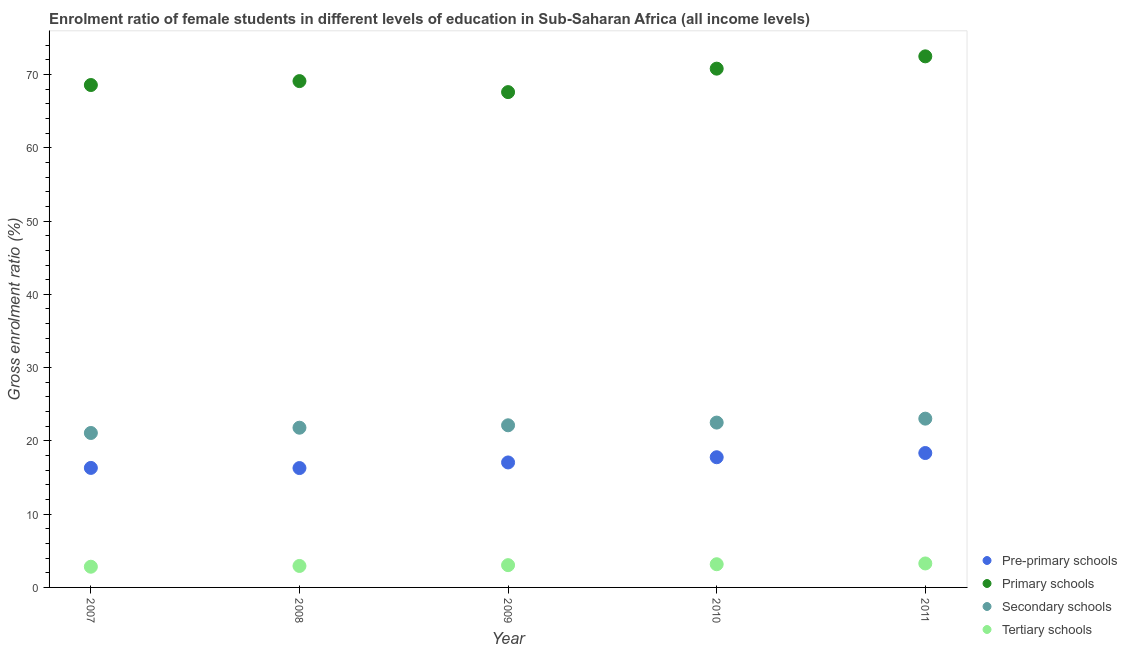How many different coloured dotlines are there?
Make the answer very short. 4. What is the gross enrolment ratio(male) in tertiary schools in 2008?
Your answer should be compact. 2.93. Across all years, what is the maximum gross enrolment ratio(male) in pre-primary schools?
Make the answer very short. 18.34. Across all years, what is the minimum gross enrolment ratio(male) in pre-primary schools?
Offer a terse response. 16.29. In which year was the gross enrolment ratio(male) in primary schools maximum?
Offer a very short reply. 2011. In which year was the gross enrolment ratio(male) in primary schools minimum?
Your answer should be compact. 2009. What is the total gross enrolment ratio(male) in primary schools in the graph?
Offer a very short reply. 348.55. What is the difference between the gross enrolment ratio(male) in secondary schools in 2009 and that in 2010?
Make the answer very short. -0.37. What is the difference between the gross enrolment ratio(male) in primary schools in 2008 and the gross enrolment ratio(male) in secondary schools in 2009?
Provide a succinct answer. 46.97. What is the average gross enrolment ratio(male) in pre-primary schools per year?
Offer a terse response. 17.15. In the year 2010, what is the difference between the gross enrolment ratio(male) in tertiary schools and gross enrolment ratio(male) in primary schools?
Your answer should be very brief. -67.64. In how many years, is the gross enrolment ratio(male) in pre-primary schools greater than 24 %?
Give a very brief answer. 0. What is the ratio of the gross enrolment ratio(male) in pre-primary schools in 2007 to that in 2009?
Keep it short and to the point. 0.96. Is the gross enrolment ratio(male) in primary schools in 2008 less than that in 2010?
Offer a terse response. Yes. Is the difference between the gross enrolment ratio(male) in primary schools in 2008 and 2011 greater than the difference between the gross enrolment ratio(male) in secondary schools in 2008 and 2011?
Your answer should be very brief. No. What is the difference between the highest and the second highest gross enrolment ratio(male) in pre-primary schools?
Your response must be concise. 0.57. What is the difference between the highest and the lowest gross enrolment ratio(male) in tertiary schools?
Make the answer very short. 0.45. Is it the case that in every year, the sum of the gross enrolment ratio(male) in tertiary schools and gross enrolment ratio(male) in secondary schools is greater than the sum of gross enrolment ratio(male) in pre-primary schools and gross enrolment ratio(male) in primary schools?
Your answer should be compact. No. Is it the case that in every year, the sum of the gross enrolment ratio(male) in pre-primary schools and gross enrolment ratio(male) in primary schools is greater than the gross enrolment ratio(male) in secondary schools?
Your answer should be compact. Yes. Does the gross enrolment ratio(male) in secondary schools monotonically increase over the years?
Provide a succinct answer. Yes. Is the gross enrolment ratio(male) in primary schools strictly greater than the gross enrolment ratio(male) in secondary schools over the years?
Make the answer very short. Yes. How many dotlines are there?
Make the answer very short. 4. How many years are there in the graph?
Your answer should be compact. 5. Are the values on the major ticks of Y-axis written in scientific E-notation?
Offer a very short reply. No. Does the graph contain any zero values?
Keep it short and to the point. No. How many legend labels are there?
Your answer should be very brief. 4. How are the legend labels stacked?
Offer a very short reply. Vertical. What is the title of the graph?
Make the answer very short. Enrolment ratio of female students in different levels of education in Sub-Saharan Africa (all income levels). Does "Fish species" appear as one of the legend labels in the graph?
Your answer should be compact. No. What is the Gross enrolment ratio (%) in Pre-primary schools in 2007?
Your response must be concise. 16.31. What is the Gross enrolment ratio (%) in Primary schools in 2007?
Your answer should be compact. 68.57. What is the Gross enrolment ratio (%) in Secondary schools in 2007?
Offer a very short reply. 21.08. What is the Gross enrolment ratio (%) in Tertiary schools in 2007?
Your response must be concise. 2.83. What is the Gross enrolment ratio (%) of Pre-primary schools in 2008?
Make the answer very short. 16.29. What is the Gross enrolment ratio (%) in Primary schools in 2008?
Your answer should be compact. 69.1. What is the Gross enrolment ratio (%) in Secondary schools in 2008?
Keep it short and to the point. 21.8. What is the Gross enrolment ratio (%) of Tertiary schools in 2008?
Give a very brief answer. 2.93. What is the Gross enrolment ratio (%) in Pre-primary schools in 2009?
Your answer should be very brief. 17.06. What is the Gross enrolment ratio (%) of Primary schools in 2009?
Provide a short and direct response. 67.6. What is the Gross enrolment ratio (%) in Secondary schools in 2009?
Your answer should be compact. 22.13. What is the Gross enrolment ratio (%) in Tertiary schools in 2009?
Give a very brief answer. 3.04. What is the Gross enrolment ratio (%) of Pre-primary schools in 2010?
Offer a terse response. 17.77. What is the Gross enrolment ratio (%) in Primary schools in 2010?
Your answer should be very brief. 70.8. What is the Gross enrolment ratio (%) in Secondary schools in 2010?
Provide a succinct answer. 22.5. What is the Gross enrolment ratio (%) of Tertiary schools in 2010?
Keep it short and to the point. 3.17. What is the Gross enrolment ratio (%) of Pre-primary schools in 2011?
Offer a very short reply. 18.34. What is the Gross enrolment ratio (%) in Primary schools in 2011?
Offer a very short reply. 72.48. What is the Gross enrolment ratio (%) in Secondary schools in 2011?
Make the answer very short. 23.04. What is the Gross enrolment ratio (%) of Tertiary schools in 2011?
Provide a short and direct response. 3.27. Across all years, what is the maximum Gross enrolment ratio (%) in Pre-primary schools?
Keep it short and to the point. 18.34. Across all years, what is the maximum Gross enrolment ratio (%) in Primary schools?
Your response must be concise. 72.48. Across all years, what is the maximum Gross enrolment ratio (%) in Secondary schools?
Provide a short and direct response. 23.04. Across all years, what is the maximum Gross enrolment ratio (%) of Tertiary schools?
Provide a succinct answer. 3.27. Across all years, what is the minimum Gross enrolment ratio (%) of Pre-primary schools?
Your answer should be compact. 16.29. Across all years, what is the minimum Gross enrolment ratio (%) in Primary schools?
Provide a succinct answer. 67.6. Across all years, what is the minimum Gross enrolment ratio (%) in Secondary schools?
Provide a short and direct response. 21.08. Across all years, what is the minimum Gross enrolment ratio (%) in Tertiary schools?
Your answer should be compact. 2.83. What is the total Gross enrolment ratio (%) in Pre-primary schools in the graph?
Provide a short and direct response. 85.77. What is the total Gross enrolment ratio (%) of Primary schools in the graph?
Your response must be concise. 348.55. What is the total Gross enrolment ratio (%) in Secondary schools in the graph?
Give a very brief answer. 110.54. What is the total Gross enrolment ratio (%) in Tertiary schools in the graph?
Your answer should be very brief. 15.23. What is the difference between the Gross enrolment ratio (%) of Pre-primary schools in 2007 and that in 2008?
Offer a very short reply. 0.02. What is the difference between the Gross enrolment ratio (%) of Primary schools in 2007 and that in 2008?
Provide a short and direct response. -0.54. What is the difference between the Gross enrolment ratio (%) in Secondary schools in 2007 and that in 2008?
Provide a short and direct response. -0.72. What is the difference between the Gross enrolment ratio (%) of Tertiary schools in 2007 and that in 2008?
Your answer should be very brief. -0.1. What is the difference between the Gross enrolment ratio (%) of Pre-primary schools in 2007 and that in 2009?
Your answer should be very brief. -0.75. What is the difference between the Gross enrolment ratio (%) in Primary schools in 2007 and that in 2009?
Make the answer very short. 0.97. What is the difference between the Gross enrolment ratio (%) in Secondary schools in 2007 and that in 2009?
Offer a very short reply. -1.05. What is the difference between the Gross enrolment ratio (%) of Tertiary schools in 2007 and that in 2009?
Provide a short and direct response. -0.22. What is the difference between the Gross enrolment ratio (%) of Pre-primary schools in 2007 and that in 2010?
Give a very brief answer. -1.46. What is the difference between the Gross enrolment ratio (%) in Primary schools in 2007 and that in 2010?
Make the answer very short. -2.24. What is the difference between the Gross enrolment ratio (%) in Secondary schools in 2007 and that in 2010?
Provide a short and direct response. -1.42. What is the difference between the Gross enrolment ratio (%) in Tertiary schools in 2007 and that in 2010?
Your response must be concise. -0.34. What is the difference between the Gross enrolment ratio (%) in Pre-primary schools in 2007 and that in 2011?
Keep it short and to the point. -2.03. What is the difference between the Gross enrolment ratio (%) in Primary schools in 2007 and that in 2011?
Provide a succinct answer. -3.92. What is the difference between the Gross enrolment ratio (%) in Secondary schools in 2007 and that in 2011?
Make the answer very short. -1.96. What is the difference between the Gross enrolment ratio (%) in Tertiary schools in 2007 and that in 2011?
Provide a succinct answer. -0.45. What is the difference between the Gross enrolment ratio (%) of Pre-primary schools in 2008 and that in 2009?
Your answer should be very brief. -0.77. What is the difference between the Gross enrolment ratio (%) of Primary schools in 2008 and that in 2009?
Provide a short and direct response. 1.5. What is the difference between the Gross enrolment ratio (%) of Secondary schools in 2008 and that in 2009?
Offer a terse response. -0.33. What is the difference between the Gross enrolment ratio (%) in Tertiary schools in 2008 and that in 2009?
Your answer should be very brief. -0.11. What is the difference between the Gross enrolment ratio (%) in Pre-primary schools in 2008 and that in 2010?
Your response must be concise. -1.48. What is the difference between the Gross enrolment ratio (%) in Primary schools in 2008 and that in 2010?
Offer a terse response. -1.7. What is the difference between the Gross enrolment ratio (%) of Secondary schools in 2008 and that in 2010?
Make the answer very short. -0.7. What is the difference between the Gross enrolment ratio (%) of Tertiary schools in 2008 and that in 2010?
Provide a short and direct response. -0.24. What is the difference between the Gross enrolment ratio (%) of Pre-primary schools in 2008 and that in 2011?
Give a very brief answer. -2.05. What is the difference between the Gross enrolment ratio (%) in Primary schools in 2008 and that in 2011?
Ensure brevity in your answer.  -3.38. What is the difference between the Gross enrolment ratio (%) in Secondary schools in 2008 and that in 2011?
Give a very brief answer. -1.24. What is the difference between the Gross enrolment ratio (%) of Tertiary schools in 2008 and that in 2011?
Your answer should be very brief. -0.34. What is the difference between the Gross enrolment ratio (%) of Pre-primary schools in 2009 and that in 2010?
Keep it short and to the point. -0.71. What is the difference between the Gross enrolment ratio (%) in Primary schools in 2009 and that in 2010?
Offer a very short reply. -3.2. What is the difference between the Gross enrolment ratio (%) in Secondary schools in 2009 and that in 2010?
Provide a succinct answer. -0.37. What is the difference between the Gross enrolment ratio (%) in Tertiary schools in 2009 and that in 2010?
Offer a terse response. -0.13. What is the difference between the Gross enrolment ratio (%) in Pre-primary schools in 2009 and that in 2011?
Your answer should be very brief. -1.28. What is the difference between the Gross enrolment ratio (%) of Primary schools in 2009 and that in 2011?
Make the answer very short. -4.88. What is the difference between the Gross enrolment ratio (%) in Secondary schools in 2009 and that in 2011?
Your response must be concise. -0.91. What is the difference between the Gross enrolment ratio (%) in Tertiary schools in 2009 and that in 2011?
Keep it short and to the point. -0.23. What is the difference between the Gross enrolment ratio (%) in Pre-primary schools in 2010 and that in 2011?
Provide a short and direct response. -0.57. What is the difference between the Gross enrolment ratio (%) in Primary schools in 2010 and that in 2011?
Keep it short and to the point. -1.68. What is the difference between the Gross enrolment ratio (%) of Secondary schools in 2010 and that in 2011?
Your answer should be compact. -0.54. What is the difference between the Gross enrolment ratio (%) of Tertiary schools in 2010 and that in 2011?
Give a very brief answer. -0.11. What is the difference between the Gross enrolment ratio (%) of Pre-primary schools in 2007 and the Gross enrolment ratio (%) of Primary schools in 2008?
Give a very brief answer. -52.79. What is the difference between the Gross enrolment ratio (%) of Pre-primary schools in 2007 and the Gross enrolment ratio (%) of Secondary schools in 2008?
Your response must be concise. -5.49. What is the difference between the Gross enrolment ratio (%) in Pre-primary schools in 2007 and the Gross enrolment ratio (%) in Tertiary schools in 2008?
Keep it short and to the point. 13.38. What is the difference between the Gross enrolment ratio (%) of Primary schools in 2007 and the Gross enrolment ratio (%) of Secondary schools in 2008?
Make the answer very short. 46.77. What is the difference between the Gross enrolment ratio (%) in Primary schools in 2007 and the Gross enrolment ratio (%) in Tertiary schools in 2008?
Make the answer very short. 65.64. What is the difference between the Gross enrolment ratio (%) of Secondary schools in 2007 and the Gross enrolment ratio (%) of Tertiary schools in 2008?
Offer a very short reply. 18.15. What is the difference between the Gross enrolment ratio (%) of Pre-primary schools in 2007 and the Gross enrolment ratio (%) of Primary schools in 2009?
Make the answer very short. -51.29. What is the difference between the Gross enrolment ratio (%) of Pre-primary schools in 2007 and the Gross enrolment ratio (%) of Secondary schools in 2009?
Offer a terse response. -5.82. What is the difference between the Gross enrolment ratio (%) of Pre-primary schools in 2007 and the Gross enrolment ratio (%) of Tertiary schools in 2009?
Make the answer very short. 13.27. What is the difference between the Gross enrolment ratio (%) of Primary schools in 2007 and the Gross enrolment ratio (%) of Secondary schools in 2009?
Offer a terse response. 46.44. What is the difference between the Gross enrolment ratio (%) in Primary schools in 2007 and the Gross enrolment ratio (%) in Tertiary schools in 2009?
Your answer should be compact. 65.53. What is the difference between the Gross enrolment ratio (%) of Secondary schools in 2007 and the Gross enrolment ratio (%) of Tertiary schools in 2009?
Your answer should be very brief. 18.04. What is the difference between the Gross enrolment ratio (%) in Pre-primary schools in 2007 and the Gross enrolment ratio (%) in Primary schools in 2010?
Make the answer very short. -54.49. What is the difference between the Gross enrolment ratio (%) in Pre-primary schools in 2007 and the Gross enrolment ratio (%) in Secondary schools in 2010?
Your answer should be compact. -6.19. What is the difference between the Gross enrolment ratio (%) in Pre-primary schools in 2007 and the Gross enrolment ratio (%) in Tertiary schools in 2010?
Ensure brevity in your answer.  13.14. What is the difference between the Gross enrolment ratio (%) in Primary schools in 2007 and the Gross enrolment ratio (%) in Secondary schools in 2010?
Offer a terse response. 46.07. What is the difference between the Gross enrolment ratio (%) of Primary schools in 2007 and the Gross enrolment ratio (%) of Tertiary schools in 2010?
Your response must be concise. 65.4. What is the difference between the Gross enrolment ratio (%) in Secondary schools in 2007 and the Gross enrolment ratio (%) in Tertiary schools in 2010?
Keep it short and to the point. 17.91. What is the difference between the Gross enrolment ratio (%) of Pre-primary schools in 2007 and the Gross enrolment ratio (%) of Primary schools in 2011?
Offer a very short reply. -56.17. What is the difference between the Gross enrolment ratio (%) of Pre-primary schools in 2007 and the Gross enrolment ratio (%) of Secondary schools in 2011?
Your response must be concise. -6.72. What is the difference between the Gross enrolment ratio (%) of Pre-primary schools in 2007 and the Gross enrolment ratio (%) of Tertiary schools in 2011?
Give a very brief answer. 13.04. What is the difference between the Gross enrolment ratio (%) of Primary schools in 2007 and the Gross enrolment ratio (%) of Secondary schools in 2011?
Keep it short and to the point. 45.53. What is the difference between the Gross enrolment ratio (%) of Primary schools in 2007 and the Gross enrolment ratio (%) of Tertiary schools in 2011?
Give a very brief answer. 65.3. What is the difference between the Gross enrolment ratio (%) of Secondary schools in 2007 and the Gross enrolment ratio (%) of Tertiary schools in 2011?
Give a very brief answer. 17.81. What is the difference between the Gross enrolment ratio (%) of Pre-primary schools in 2008 and the Gross enrolment ratio (%) of Primary schools in 2009?
Offer a terse response. -51.31. What is the difference between the Gross enrolment ratio (%) of Pre-primary schools in 2008 and the Gross enrolment ratio (%) of Secondary schools in 2009?
Provide a short and direct response. -5.84. What is the difference between the Gross enrolment ratio (%) in Pre-primary schools in 2008 and the Gross enrolment ratio (%) in Tertiary schools in 2009?
Your answer should be very brief. 13.25. What is the difference between the Gross enrolment ratio (%) of Primary schools in 2008 and the Gross enrolment ratio (%) of Secondary schools in 2009?
Give a very brief answer. 46.97. What is the difference between the Gross enrolment ratio (%) in Primary schools in 2008 and the Gross enrolment ratio (%) in Tertiary schools in 2009?
Your answer should be very brief. 66.06. What is the difference between the Gross enrolment ratio (%) of Secondary schools in 2008 and the Gross enrolment ratio (%) of Tertiary schools in 2009?
Make the answer very short. 18.76. What is the difference between the Gross enrolment ratio (%) of Pre-primary schools in 2008 and the Gross enrolment ratio (%) of Primary schools in 2010?
Provide a short and direct response. -54.51. What is the difference between the Gross enrolment ratio (%) of Pre-primary schools in 2008 and the Gross enrolment ratio (%) of Secondary schools in 2010?
Provide a succinct answer. -6.21. What is the difference between the Gross enrolment ratio (%) of Pre-primary schools in 2008 and the Gross enrolment ratio (%) of Tertiary schools in 2010?
Your response must be concise. 13.13. What is the difference between the Gross enrolment ratio (%) in Primary schools in 2008 and the Gross enrolment ratio (%) in Secondary schools in 2010?
Provide a short and direct response. 46.61. What is the difference between the Gross enrolment ratio (%) of Primary schools in 2008 and the Gross enrolment ratio (%) of Tertiary schools in 2010?
Provide a succinct answer. 65.94. What is the difference between the Gross enrolment ratio (%) of Secondary schools in 2008 and the Gross enrolment ratio (%) of Tertiary schools in 2010?
Ensure brevity in your answer.  18.63. What is the difference between the Gross enrolment ratio (%) of Pre-primary schools in 2008 and the Gross enrolment ratio (%) of Primary schools in 2011?
Your answer should be very brief. -56.19. What is the difference between the Gross enrolment ratio (%) in Pre-primary schools in 2008 and the Gross enrolment ratio (%) in Secondary schools in 2011?
Offer a terse response. -6.74. What is the difference between the Gross enrolment ratio (%) in Pre-primary schools in 2008 and the Gross enrolment ratio (%) in Tertiary schools in 2011?
Provide a short and direct response. 13.02. What is the difference between the Gross enrolment ratio (%) in Primary schools in 2008 and the Gross enrolment ratio (%) in Secondary schools in 2011?
Keep it short and to the point. 46.07. What is the difference between the Gross enrolment ratio (%) of Primary schools in 2008 and the Gross enrolment ratio (%) of Tertiary schools in 2011?
Give a very brief answer. 65.83. What is the difference between the Gross enrolment ratio (%) in Secondary schools in 2008 and the Gross enrolment ratio (%) in Tertiary schools in 2011?
Your response must be concise. 18.53. What is the difference between the Gross enrolment ratio (%) of Pre-primary schools in 2009 and the Gross enrolment ratio (%) of Primary schools in 2010?
Offer a very short reply. -53.74. What is the difference between the Gross enrolment ratio (%) in Pre-primary schools in 2009 and the Gross enrolment ratio (%) in Secondary schools in 2010?
Offer a very short reply. -5.44. What is the difference between the Gross enrolment ratio (%) of Pre-primary schools in 2009 and the Gross enrolment ratio (%) of Tertiary schools in 2010?
Your answer should be very brief. 13.89. What is the difference between the Gross enrolment ratio (%) of Primary schools in 2009 and the Gross enrolment ratio (%) of Secondary schools in 2010?
Provide a short and direct response. 45.1. What is the difference between the Gross enrolment ratio (%) of Primary schools in 2009 and the Gross enrolment ratio (%) of Tertiary schools in 2010?
Provide a short and direct response. 64.43. What is the difference between the Gross enrolment ratio (%) of Secondary schools in 2009 and the Gross enrolment ratio (%) of Tertiary schools in 2010?
Keep it short and to the point. 18.96. What is the difference between the Gross enrolment ratio (%) of Pre-primary schools in 2009 and the Gross enrolment ratio (%) of Primary schools in 2011?
Offer a terse response. -55.42. What is the difference between the Gross enrolment ratio (%) in Pre-primary schools in 2009 and the Gross enrolment ratio (%) in Secondary schools in 2011?
Make the answer very short. -5.98. What is the difference between the Gross enrolment ratio (%) of Pre-primary schools in 2009 and the Gross enrolment ratio (%) of Tertiary schools in 2011?
Provide a short and direct response. 13.79. What is the difference between the Gross enrolment ratio (%) in Primary schools in 2009 and the Gross enrolment ratio (%) in Secondary schools in 2011?
Make the answer very short. 44.56. What is the difference between the Gross enrolment ratio (%) in Primary schools in 2009 and the Gross enrolment ratio (%) in Tertiary schools in 2011?
Give a very brief answer. 64.33. What is the difference between the Gross enrolment ratio (%) in Secondary schools in 2009 and the Gross enrolment ratio (%) in Tertiary schools in 2011?
Provide a short and direct response. 18.86. What is the difference between the Gross enrolment ratio (%) in Pre-primary schools in 2010 and the Gross enrolment ratio (%) in Primary schools in 2011?
Offer a very short reply. -54.71. What is the difference between the Gross enrolment ratio (%) in Pre-primary schools in 2010 and the Gross enrolment ratio (%) in Secondary schools in 2011?
Keep it short and to the point. -5.27. What is the difference between the Gross enrolment ratio (%) in Pre-primary schools in 2010 and the Gross enrolment ratio (%) in Tertiary schools in 2011?
Ensure brevity in your answer.  14.5. What is the difference between the Gross enrolment ratio (%) of Primary schools in 2010 and the Gross enrolment ratio (%) of Secondary schools in 2011?
Keep it short and to the point. 47.77. What is the difference between the Gross enrolment ratio (%) of Primary schools in 2010 and the Gross enrolment ratio (%) of Tertiary schools in 2011?
Provide a succinct answer. 67.53. What is the difference between the Gross enrolment ratio (%) of Secondary schools in 2010 and the Gross enrolment ratio (%) of Tertiary schools in 2011?
Your answer should be very brief. 19.23. What is the average Gross enrolment ratio (%) in Pre-primary schools per year?
Offer a very short reply. 17.15. What is the average Gross enrolment ratio (%) of Primary schools per year?
Offer a very short reply. 69.71. What is the average Gross enrolment ratio (%) in Secondary schools per year?
Your response must be concise. 22.11. What is the average Gross enrolment ratio (%) in Tertiary schools per year?
Offer a very short reply. 3.05. In the year 2007, what is the difference between the Gross enrolment ratio (%) of Pre-primary schools and Gross enrolment ratio (%) of Primary schools?
Make the answer very short. -52.26. In the year 2007, what is the difference between the Gross enrolment ratio (%) in Pre-primary schools and Gross enrolment ratio (%) in Secondary schools?
Provide a short and direct response. -4.77. In the year 2007, what is the difference between the Gross enrolment ratio (%) in Pre-primary schools and Gross enrolment ratio (%) in Tertiary schools?
Provide a short and direct response. 13.49. In the year 2007, what is the difference between the Gross enrolment ratio (%) in Primary schools and Gross enrolment ratio (%) in Secondary schools?
Your answer should be compact. 47.49. In the year 2007, what is the difference between the Gross enrolment ratio (%) of Primary schools and Gross enrolment ratio (%) of Tertiary schools?
Keep it short and to the point. 65.74. In the year 2007, what is the difference between the Gross enrolment ratio (%) of Secondary schools and Gross enrolment ratio (%) of Tertiary schools?
Offer a terse response. 18.25. In the year 2008, what is the difference between the Gross enrolment ratio (%) in Pre-primary schools and Gross enrolment ratio (%) in Primary schools?
Keep it short and to the point. -52.81. In the year 2008, what is the difference between the Gross enrolment ratio (%) in Pre-primary schools and Gross enrolment ratio (%) in Secondary schools?
Provide a succinct answer. -5.51. In the year 2008, what is the difference between the Gross enrolment ratio (%) in Pre-primary schools and Gross enrolment ratio (%) in Tertiary schools?
Keep it short and to the point. 13.36. In the year 2008, what is the difference between the Gross enrolment ratio (%) in Primary schools and Gross enrolment ratio (%) in Secondary schools?
Keep it short and to the point. 47.31. In the year 2008, what is the difference between the Gross enrolment ratio (%) of Primary schools and Gross enrolment ratio (%) of Tertiary schools?
Offer a terse response. 66.17. In the year 2008, what is the difference between the Gross enrolment ratio (%) of Secondary schools and Gross enrolment ratio (%) of Tertiary schools?
Your answer should be very brief. 18.87. In the year 2009, what is the difference between the Gross enrolment ratio (%) of Pre-primary schools and Gross enrolment ratio (%) of Primary schools?
Your answer should be very brief. -50.54. In the year 2009, what is the difference between the Gross enrolment ratio (%) in Pre-primary schools and Gross enrolment ratio (%) in Secondary schools?
Your answer should be compact. -5.07. In the year 2009, what is the difference between the Gross enrolment ratio (%) in Pre-primary schools and Gross enrolment ratio (%) in Tertiary schools?
Your response must be concise. 14.02. In the year 2009, what is the difference between the Gross enrolment ratio (%) of Primary schools and Gross enrolment ratio (%) of Secondary schools?
Keep it short and to the point. 45.47. In the year 2009, what is the difference between the Gross enrolment ratio (%) in Primary schools and Gross enrolment ratio (%) in Tertiary schools?
Provide a succinct answer. 64.56. In the year 2009, what is the difference between the Gross enrolment ratio (%) of Secondary schools and Gross enrolment ratio (%) of Tertiary schools?
Offer a terse response. 19.09. In the year 2010, what is the difference between the Gross enrolment ratio (%) in Pre-primary schools and Gross enrolment ratio (%) in Primary schools?
Your answer should be very brief. -53.03. In the year 2010, what is the difference between the Gross enrolment ratio (%) of Pre-primary schools and Gross enrolment ratio (%) of Secondary schools?
Offer a terse response. -4.73. In the year 2010, what is the difference between the Gross enrolment ratio (%) of Pre-primary schools and Gross enrolment ratio (%) of Tertiary schools?
Your answer should be compact. 14.6. In the year 2010, what is the difference between the Gross enrolment ratio (%) of Primary schools and Gross enrolment ratio (%) of Secondary schools?
Your answer should be compact. 48.3. In the year 2010, what is the difference between the Gross enrolment ratio (%) of Primary schools and Gross enrolment ratio (%) of Tertiary schools?
Your answer should be very brief. 67.64. In the year 2010, what is the difference between the Gross enrolment ratio (%) in Secondary schools and Gross enrolment ratio (%) in Tertiary schools?
Provide a succinct answer. 19.33. In the year 2011, what is the difference between the Gross enrolment ratio (%) in Pre-primary schools and Gross enrolment ratio (%) in Primary schools?
Your answer should be very brief. -54.14. In the year 2011, what is the difference between the Gross enrolment ratio (%) of Pre-primary schools and Gross enrolment ratio (%) of Secondary schools?
Offer a very short reply. -4.69. In the year 2011, what is the difference between the Gross enrolment ratio (%) in Pre-primary schools and Gross enrolment ratio (%) in Tertiary schools?
Provide a short and direct response. 15.07. In the year 2011, what is the difference between the Gross enrolment ratio (%) in Primary schools and Gross enrolment ratio (%) in Secondary schools?
Your answer should be very brief. 49.45. In the year 2011, what is the difference between the Gross enrolment ratio (%) in Primary schools and Gross enrolment ratio (%) in Tertiary schools?
Give a very brief answer. 69.21. In the year 2011, what is the difference between the Gross enrolment ratio (%) of Secondary schools and Gross enrolment ratio (%) of Tertiary schools?
Your answer should be compact. 19.76. What is the ratio of the Gross enrolment ratio (%) in Pre-primary schools in 2007 to that in 2008?
Give a very brief answer. 1. What is the ratio of the Gross enrolment ratio (%) of Secondary schools in 2007 to that in 2008?
Offer a very short reply. 0.97. What is the ratio of the Gross enrolment ratio (%) in Tertiary schools in 2007 to that in 2008?
Your response must be concise. 0.96. What is the ratio of the Gross enrolment ratio (%) in Pre-primary schools in 2007 to that in 2009?
Your answer should be very brief. 0.96. What is the ratio of the Gross enrolment ratio (%) of Primary schools in 2007 to that in 2009?
Your answer should be very brief. 1.01. What is the ratio of the Gross enrolment ratio (%) of Secondary schools in 2007 to that in 2009?
Provide a succinct answer. 0.95. What is the ratio of the Gross enrolment ratio (%) in Tertiary schools in 2007 to that in 2009?
Your response must be concise. 0.93. What is the ratio of the Gross enrolment ratio (%) in Pre-primary schools in 2007 to that in 2010?
Provide a short and direct response. 0.92. What is the ratio of the Gross enrolment ratio (%) in Primary schools in 2007 to that in 2010?
Your response must be concise. 0.97. What is the ratio of the Gross enrolment ratio (%) of Secondary schools in 2007 to that in 2010?
Offer a very short reply. 0.94. What is the ratio of the Gross enrolment ratio (%) of Tertiary schools in 2007 to that in 2010?
Offer a very short reply. 0.89. What is the ratio of the Gross enrolment ratio (%) in Pre-primary schools in 2007 to that in 2011?
Your response must be concise. 0.89. What is the ratio of the Gross enrolment ratio (%) in Primary schools in 2007 to that in 2011?
Give a very brief answer. 0.95. What is the ratio of the Gross enrolment ratio (%) of Secondary schools in 2007 to that in 2011?
Provide a succinct answer. 0.92. What is the ratio of the Gross enrolment ratio (%) in Tertiary schools in 2007 to that in 2011?
Your answer should be compact. 0.86. What is the ratio of the Gross enrolment ratio (%) of Pre-primary schools in 2008 to that in 2009?
Give a very brief answer. 0.96. What is the ratio of the Gross enrolment ratio (%) in Primary schools in 2008 to that in 2009?
Offer a very short reply. 1.02. What is the ratio of the Gross enrolment ratio (%) of Secondary schools in 2008 to that in 2009?
Provide a short and direct response. 0.99. What is the ratio of the Gross enrolment ratio (%) in Tertiary schools in 2008 to that in 2009?
Your answer should be compact. 0.96. What is the ratio of the Gross enrolment ratio (%) of Pre-primary schools in 2008 to that in 2010?
Make the answer very short. 0.92. What is the ratio of the Gross enrolment ratio (%) of Secondary schools in 2008 to that in 2010?
Keep it short and to the point. 0.97. What is the ratio of the Gross enrolment ratio (%) in Tertiary schools in 2008 to that in 2010?
Ensure brevity in your answer.  0.93. What is the ratio of the Gross enrolment ratio (%) of Pre-primary schools in 2008 to that in 2011?
Provide a short and direct response. 0.89. What is the ratio of the Gross enrolment ratio (%) of Primary schools in 2008 to that in 2011?
Provide a succinct answer. 0.95. What is the ratio of the Gross enrolment ratio (%) of Secondary schools in 2008 to that in 2011?
Your response must be concise. 0.95. What is the ratio of the Gross enrolment ratio (%) of Tertiary schools in 2008 to that in 2011?
Your answer should be compact. 0.9. What is the ratio of the Gross enrolment ratio (%) of Pre-primary schools in 2009 to that in 2010?
Your answer should be very brief. 0.96. What is the ratio of the Gross enrolment ratio (%) of Primary schools in 2009 to that in 2010?
Provide a succinct answer. 0.95. What is the ratio of the Gross enrolment ratio (%) of Secondary schools in 2009 to that in 2010?
Ensure brevity in your answer.  0.98. What is the ratio of the Gross enrolment ratio (%) in Tertiary schools in 2009 to that in 2010?
Keep it short and to the point. 0.96. What is the ratio of the Gross enrolment ratio (%) in Pre-primary schools in 2009 to that in 2011?
Your answer should be compact. 0.93. What is the ratio of the Gross enrolment ratio (%) in Primary schools in 2009 to that in 2011?
Keep it short and to the point. 0.93. What is the ratio of the Gross enrolment ratio (%) of Secondary schools in 2009 to that in 2011?
Your response must be concise. 0.96. What is the ratio of the Gross enrolment ratio (%) in Tertiary schools in 2009 to that in 2011?
Provide a short and direct response. 0.93. What is the ratio of the Gross enrolment ratio (%) in Pre-primary schools in 2010 to that in 2011?
Offer a very short reply. 0.97. What is the ratio of the Gross enrolment ratio (%) in Primary schools in 2010 to that in 2011?
Provide a succinct answer. 0.98. What is the ratio of the Gross enrolment ratio (%) in Secondary schools in 2010 to that in 2011?
Provide a succinct answer. 0.98. What is the ratio of the Gross enrolment ratio (%) in Tertiary schools in 2010 to that in 2011?
Provide a short and direct response. 0.97. What is the difference between the highest and the second highest Gross enrolment ratio (%) in Pre-primary schools?
Offer a very short reply. 0.57. What is the difference between the highest and the second highest Gross enrolment ratio (%) in Primary schools?
Your response must be concise. 1.68. What is the difference between the highest and the second highest Gross enrolment ratio (%) of Secondary schools?
Make the answer very short. 0.54. What is the difference between the highest and the second highest Gross enrolment ratio (%) of Tertiary schools?
Provide a short and direct response. 0.11. What is the difference between the highest and the lowest Gross enrolment ratio (%) in Pre-primary schools?
Ensure brevity in your answer.  2.05. What is the difference between the highest and the lowest Gross enrolment ratio (%) of Primary schools?
Your response must be concise. 4.88. What is the difference between the highest and the lowest Gross enrolment ratio (%) of Secondary schools?
Your response must be concise. 1.96. What is the difference between the highest and the lowest Gross enrolment ratio (%) in Tertiary schools?
Make the answer very short. 0.45. 